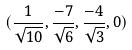Convert formula to latex. <formula><loc_0><loc_0><loc_500><loc_500>( \frac { 1 } { \sqrt { 1 0 } } , \frac { - 7 } { \sqrt { 6 } } , \frac { - 4 } { \sqrt { 3 } } , 0 )</formula> 